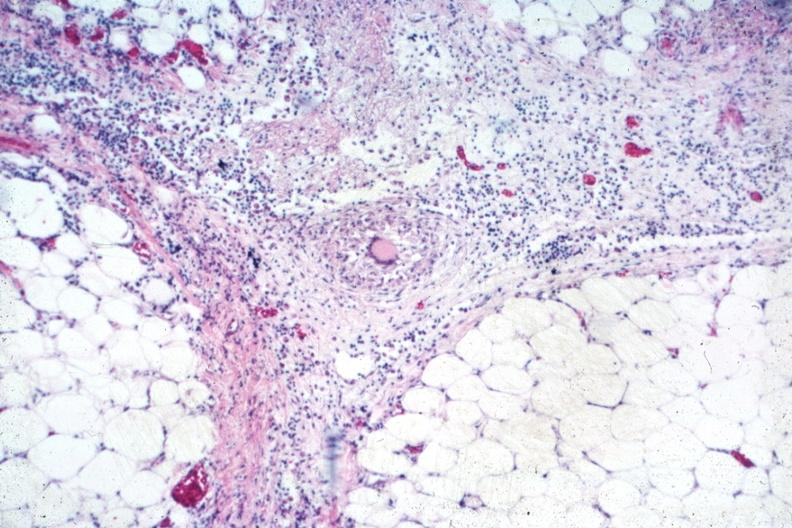does this show outstanding example of granuloma with langhans giant cell?
Answer the question using a single word or phrase. No 